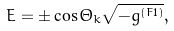Convert formula to latex. <formula><loc_0><loc_0><loc_500><loc_500>E = \pm \cos \Theta _ { k } \sqrt { - g ^ { ( F 1 ) } } ,</formula> 